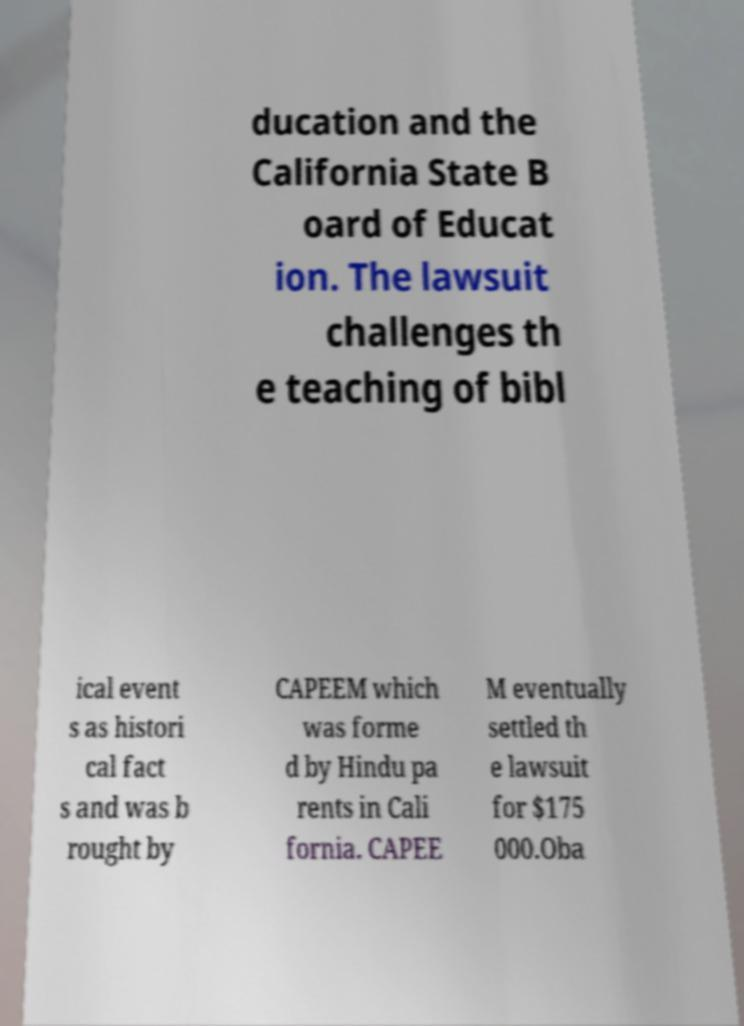Can you read and provide the text displayed in the image?This photo seems to have some interesting text. Can you extract and type it out for me? ducation and the California State B oard of Educat ion. The lawsuit challenges th e teaching of bibl ical event s as histori cal fact s and was b rought by CAPEEM which was forme d by Hindu pa rents in Cali fornia. CAPEE M eventually settled th e lawsuit for $175 000.Oba 